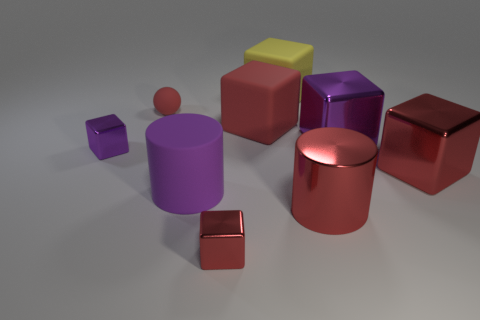There is a ball that is the same color as the large shiny cylinder; what is it made of?
Keep it short and to the point. Rubber. Is the number of large purple objects that are right of the big metal cylinder less than the number of metallic cubes that are behind the purple cylinder?
Provide a short and direct response. Yes. What number of other objects are there of the same material as the tiny red cube?
Make the answer very short. 4. What material is the other red cube that is the same size as the red rubber block?
Your response must be concise. Metal. How many purple objects are either metal objects or cylinders?
Offer a terse response. 3. There is a shiny object that is both on the left side of the red metallic cylinder and behind the red cylinder; what is its color?
Offer a very short reply. Purple. Is the material of the large cylinder that is to the right of the large purple rubber cylinder the same as the purple thing that is left of the big purple cylinder?
Ensure brevity in your answer.  Yes. Is the number of red rubber spheres that are in front of the tiny red cube greater than the number of big matte things that are behind the large purple cylinder?
Your answer should be very brief. No. There is a red object that is the same size as the sphere; what is its shape?
Offer a very short reply. Cube. What number of objects are either metal things or small red things that are behind the rubber cylinder?
Keep it short and to the point. 6. 